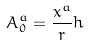Convert formula to latex. <formula><loc_0><loc_0><loc_500><loc_500>A ^ { a } _ { 0 } = \frac { x ^ { a } } { r } h</formula> 